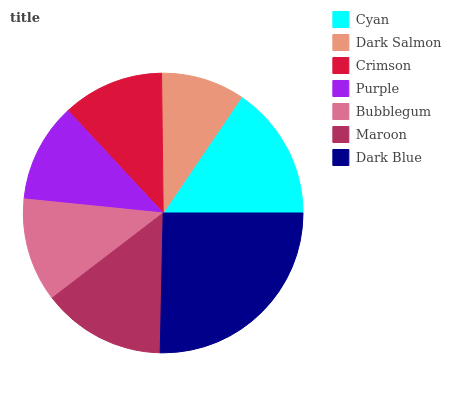Is Dark Salmon the minimum?
Answer yes or no. Yes. Is Dark Blue the maximum?
Answer yes or no. Yes. Is Crimson the minimum?
Answer yes or no. No. Is Crimson the maximum?
Answer yes or no. No. Is Crimson greater than Dark Salmon?
Answer yes or no. Yes. Is Dark Salmon less than Crimson?
Answer yes or no. Yes. Is Dark Salmon greater than Crimson?
Answer yes or no. No. Is Crimson less than Dark Salmon?
Answer yes or no. No. Is Bubblegum the high median?
Answer yes or no. Yes. Is Bubblegum the low median?
Answer yes or no. Yes. Is Purple the high median?
Answer yes or no. No. Is Cyan the low median?
Answer yes or no. No. 